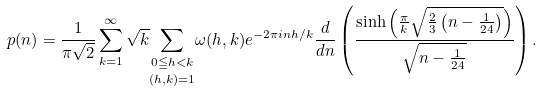<formula> <loc_0><loc_0><loc_500><loc_500>p ( n ) = \frac { 1 } { \pi \sqrt { 2 } } \sum _ { k = 1 } ^ { \infty } \sqrt { k } \underset { ( h , k ) = 1 } { \sum _ { 0 \leqq h < k } } \omega ( h , k ) e ^ { - 2 \pi i n h / k } \frac { d } { d n } \left ( \frac { \sinh \left ( \frac { \pi } { k } \sqrt { \frac { 2 } { 3 } \left ( n - \frac { 1 } { 2 4 } \right ) } \right ) } { \sqrt { n - \frac { 1 } { 2 4 } } } \right ) .</formula> 